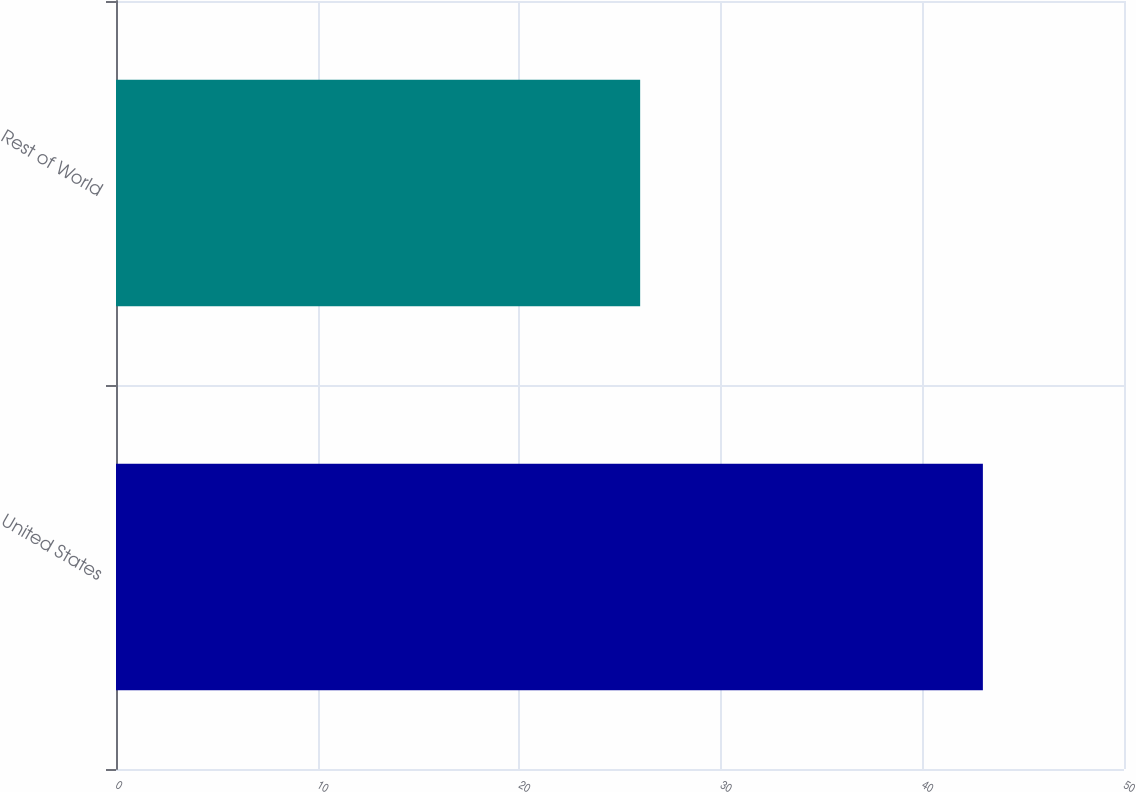Convert chart. <chart><loc_0><loc_0><loc_500><loc_500><bar_chart><fcel>United States<fcel>Rest of World<nl><fcel>43<fcel>26<nl></chart> 